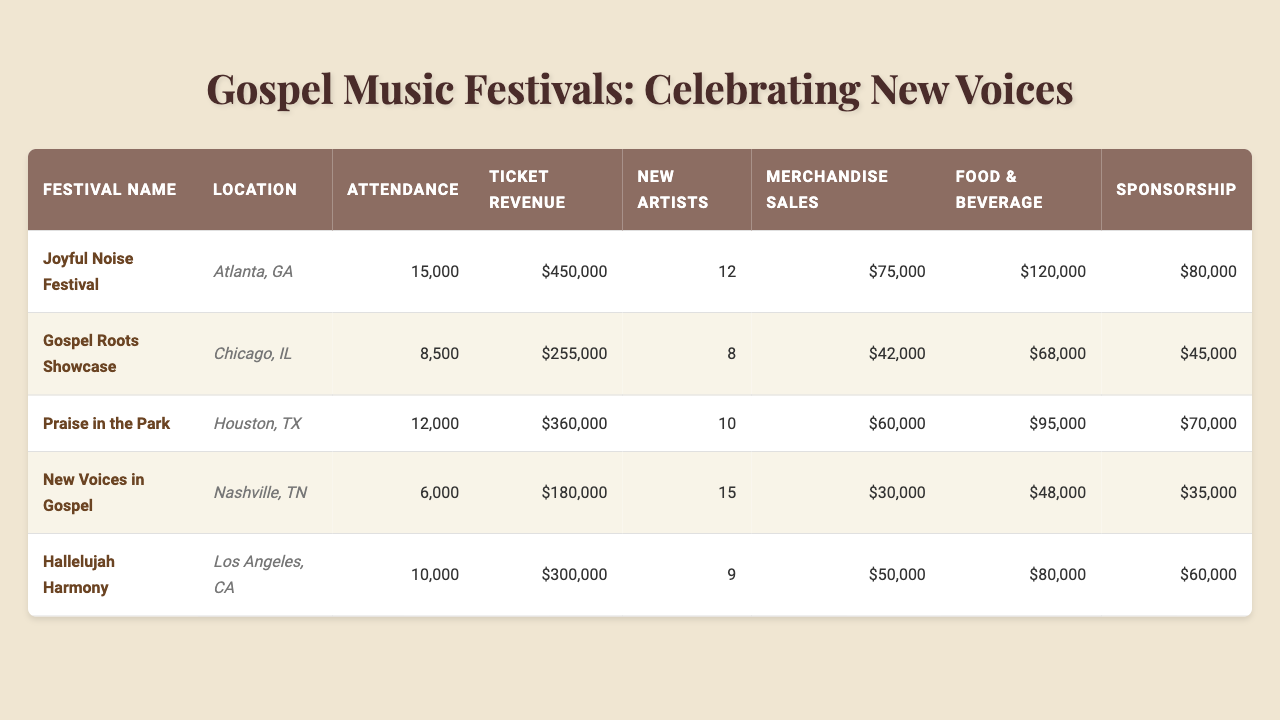What is the total attendance across all festivals? To find the total attendance, sum up the attendance figures for all festivals: 15000 + 8500 + 12000 + 6000 + 10000 = 50000.
Answer: 50000 Which festival had the highest ticket revenue? The ticket revenue figures are as follows: Joyful Noise Festival ($450,000), Gospel Roots Showcase ($255,000), Praise in the Park ($360,000), New Voices in Gospel ($180,000), Hallelujah Harmony ($300,000). The highest is $450,000 from the Joyful Noise Festival.
Answer: Joyful Noise Festival How many new artists were featured at the New Voices in Gospel festival? The table directly lists that the New Voices in Gospel festival featured 15 new artists.
Answer: 15 What is the average food and beverage revenue per festival? Sum the food and beverage revenues: 120000 + 68000 + 95000 + 48000 + 80000 = 400000. There are 5 festivals, so the average is 400000/5 = 80000.
Answer: 80000 Did the Praise in the Park festival have more merchandise sales than the New Voices in Gospel festival? Praise in the Park had merchandise sales of $60,000, while New Voices in Gospel had $30,000. Since $60,000 is greater than $30,000, the statement is true.
Answer: Yes Which festival had the highest attendance, and how many new artists were featured there? The Joyful Noise Festival had the highest attendance at 15,000, featuring 12 new artists.
Answer: Joyful Noise Festival with 12 new artists What is the total revenue from sponsorship across all festivals? Add the sponsorship income for each festival: 80000 + 45000 + 70000 + 35000 + 60000 = 290000.
Answer: 290000 Is the ticket revenue from the Hallelujah Harmony festival greater than its merchandise sales? The ticket revenue for Hallelujah Harmony is $300,000, while merchandise sales are $50,000. Since $300,000 is greater than $50,000, the statement is true.
Answer: Yes What is the difference in attendance between the Joyful Noise Festival and the New Voices in Gospel festival? Joyful Noise Festival attendance is 15,000, and New Voices in Gospel attendance is 6,000. The difference is 15000 - 6000 = 9000.
Answer: 9000 Which festival had the least attendance and what was its ticket revenue? New Voices in Gospel had the least attendance at 6,000, with ticket revenue of $180,000.
Answer: New Voices in Gospel with $180,000 ticket revenue What was the total merchandise sales across all festivals? Sum the merchandise sales: 75000 + 42000 + 60000 + 30000 + 50000 = 257000.
Answer: 257000 